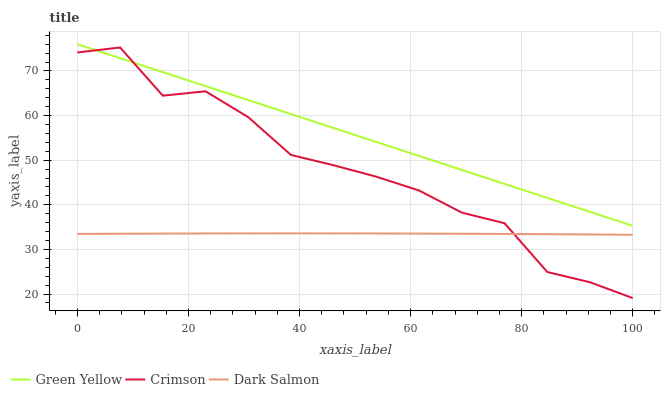Does Dark Salmon have the minimum area under the curve?
Answer yes or no. Yes. Does Green Yellow have the maximum area under the curve?
Answer yes or no. Yes. Does Green Yellow have the minimum area under the curve?
Answer yes or no. No. Does Dark Salmon have the maximum area under the curve?
Answer yes or no. No. Is Green Yellow the smoothest?
Answer yes or no. Yes. Is Crimson the roughest?
Answer yes or no. Yes. Is Dark Salmon the smoothest?
Answer yes or no. No. Is Dark Salmon the roughest?
Answer yes or no. No. Does Crimson have the lowest value?
Answer yes or no. Yes. Does Dark Salmon have the lowest value?
Answer yes or no. No. Does Green Yellow have the highest value?
Answer yes or no. Yes. Does Dark Salmon have the highest value?
Answer yes or no. No. Is Dark Salmon less than Green Yellow?
Answer yes or no. Yes. Is Green Yellow greater than Dark Salmon?
Answer yes or no. Yes. Does Crimson intersect Green Yellow?
Answer yes or no. Yes. Is Crimson less than Green Yellow?
Answer yes or no. No. Is Crimson greater than Green Yellow?
Answer yes or no. No. Does Dark Salmon intersect Green Yellow?
Answer yes or no. No. 